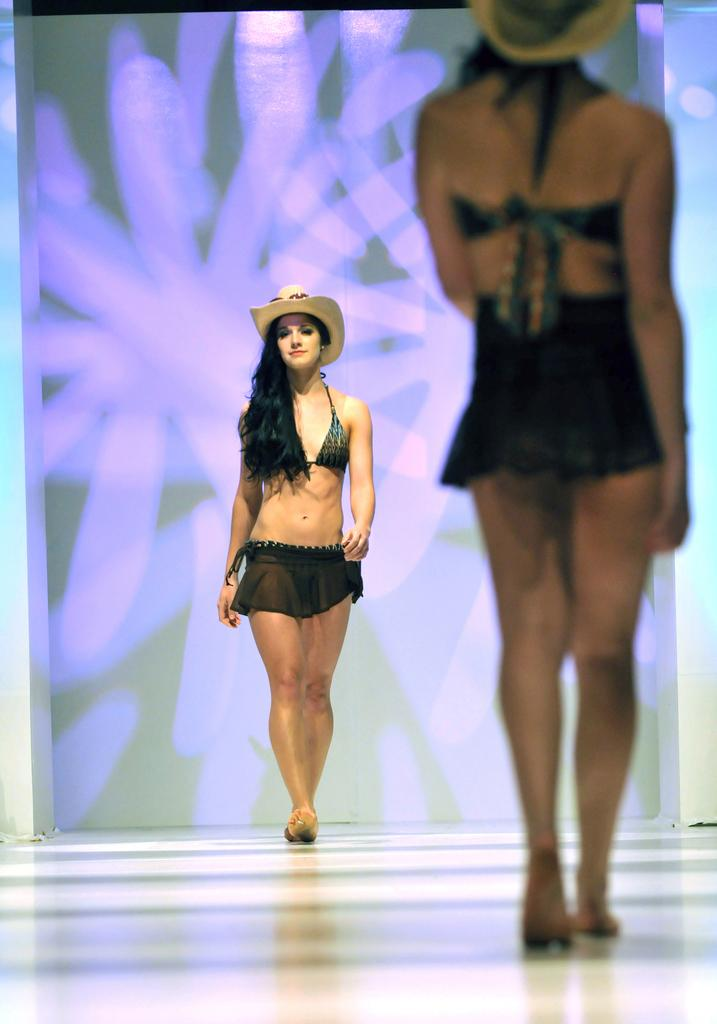How many people are in the image? There are two women in the image. What are the women doing in the image? The women are walking. What are the women wearing on their heads? The women are wearing hats. What type of lock can be seen on the father's arm in the image? There is no father or lock present in the image. How are the women transporting themselves in the image? The image does not show the provide information about how the women are transporting themselves; it only shows them walking. 